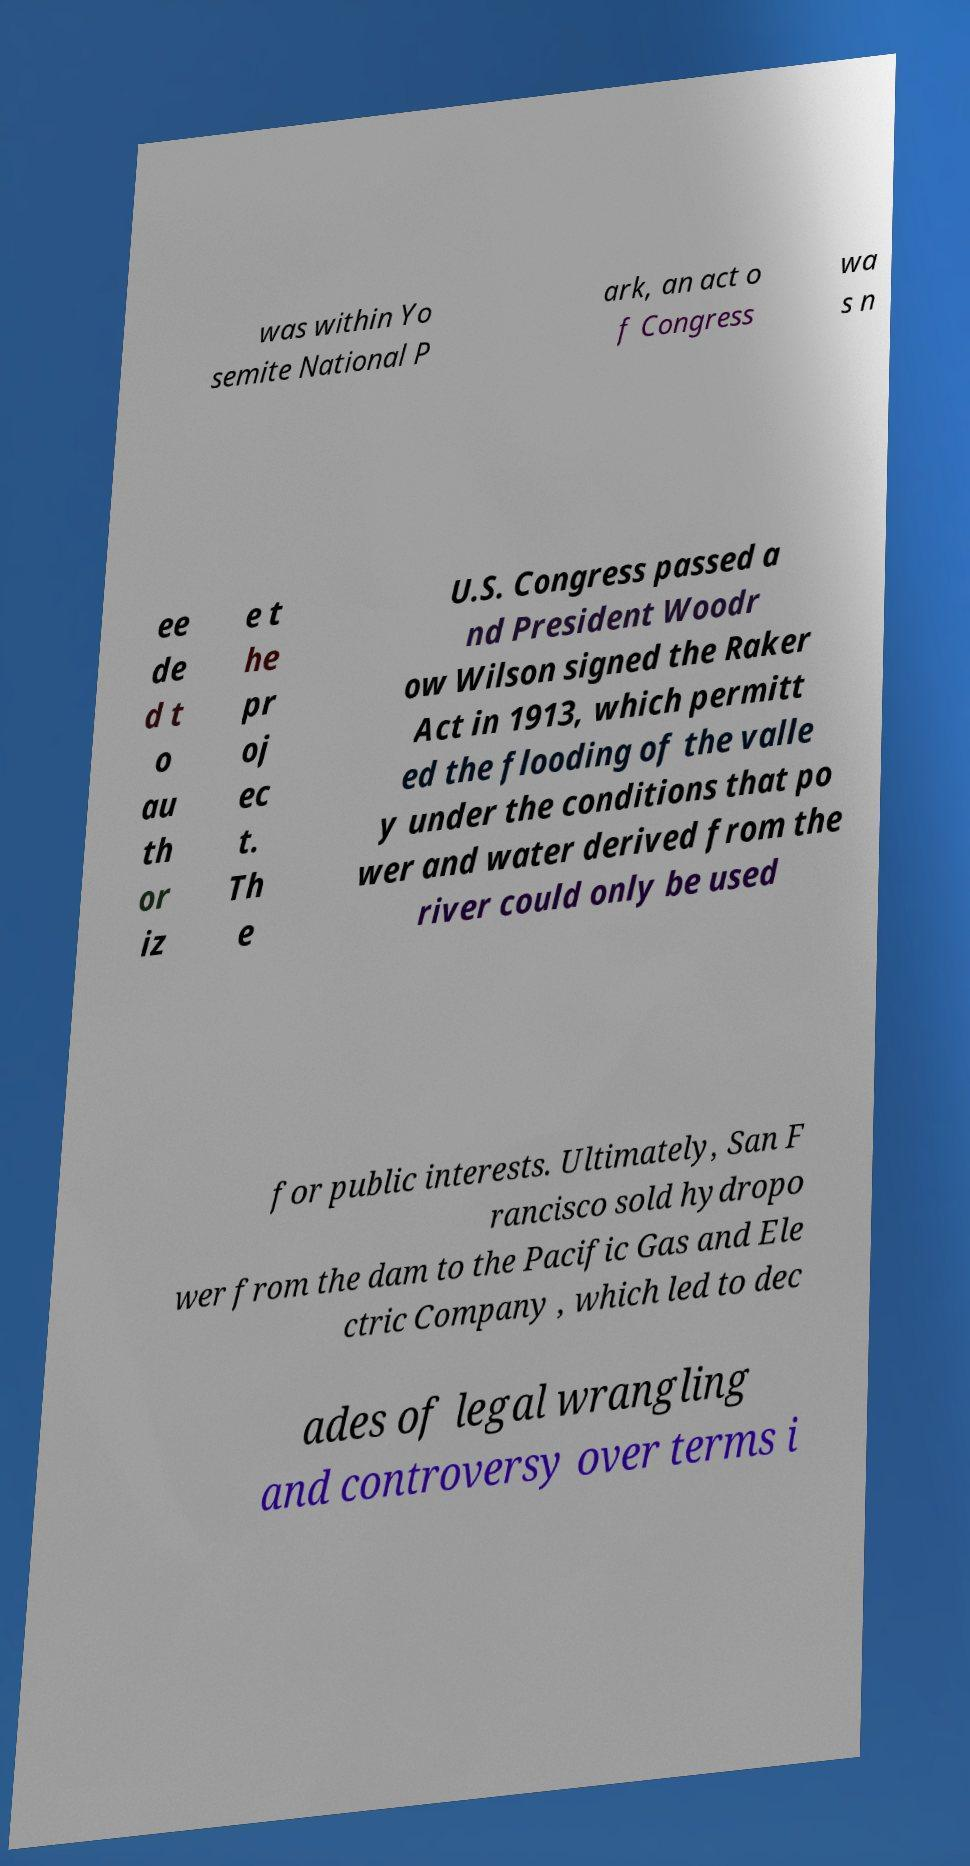For documentation purposes, I need the text within this image transcribed. Could you provide that? was within Yo semite National P ark, an act o f Congress wa s n ee de d t o au th or iz e t he pr oj ec t. Th e U.S. Congress passed a nd President Woodr ow Wilson signed the Raker Act in 1913, which permitt ed the flooding of the valle y under the conditions that po wer and water derived from the river could only be used for public interests. Ultimately, San F rancisco sold hydropo wer from the dam to the Pacific Gas and Ele ctric Company , which led to dec ades of legal wrangling and controversy over terms i 